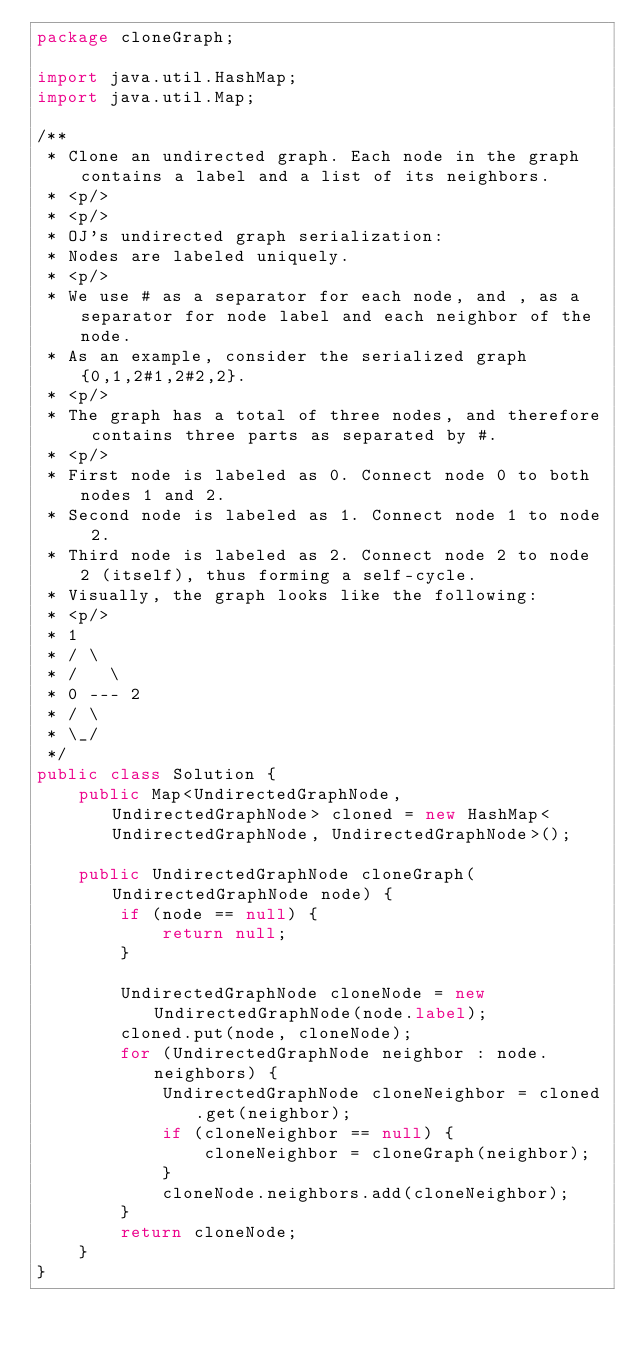Convert code to text. <code><loc_0><loc_0><loc_500><loc_500><_Java_>package cloneGraph;

import java.util.HashMap;
import java.util.Map;

/**
 * Clone an undirected graph. Each node in the graph contains a label and a list of its neighbors.
 * <p/>
 * <p/>
 * OJ's undirected graph serialization:
 * Nodes are labeled uniquely.
 * <p/>
 * We use # as a separator for each node, and , as a separator for node label and each neighbor of the node.
 * As an example, consider the serialized graph {0,1,2#1,2#2,2}.
 * <p/>
 * The graph has a total of three nodes, and therefore contains three parts as separated by #.
 * <p/>
 * First node is labeled as 0. Connect node 0 to both nodes 1 and 2.
 * Second node is labeled as 1. Connect node 1 to node 2.
 * Third node is labeled as 2. Connect node 2 to node 2 (itself), thus forming a self-cycle.
 * Visually, the graph looks like the following:
 * <p/>
 * 1
 * / \
 * /   \
 * 0 --- 2
 * / \
 * \_/
 */
public class Solution {
    public Map<UndirectedGraphNode, UndirectedGraphNode> cloned = new HashMap<UndirectedGraphNode, UndirectedGraphNode>();

    public UndirectedGraphNode cloneGraph(UndirectedGraphNode node) {
        if (node == null) {
            return null;
        }

        UndirectedGraphNode cloneNode = new UndirectedGraphNode(node.label);
        cloned.put(node, cloneNode);
        for (UndirectedGraphNode neighbor : node.neighbors) {
            UndirectedGraphNode cloneNeighbor = cloned.get(neighbor);
            if (cloneNeighbor == null) {
                cloneNeighbor = cloneGraph(neighbor);
            }
            cloneNode.neighbors.add(cloneNeighbor);
        }
        return cloneNode;
    }
}
</code> 